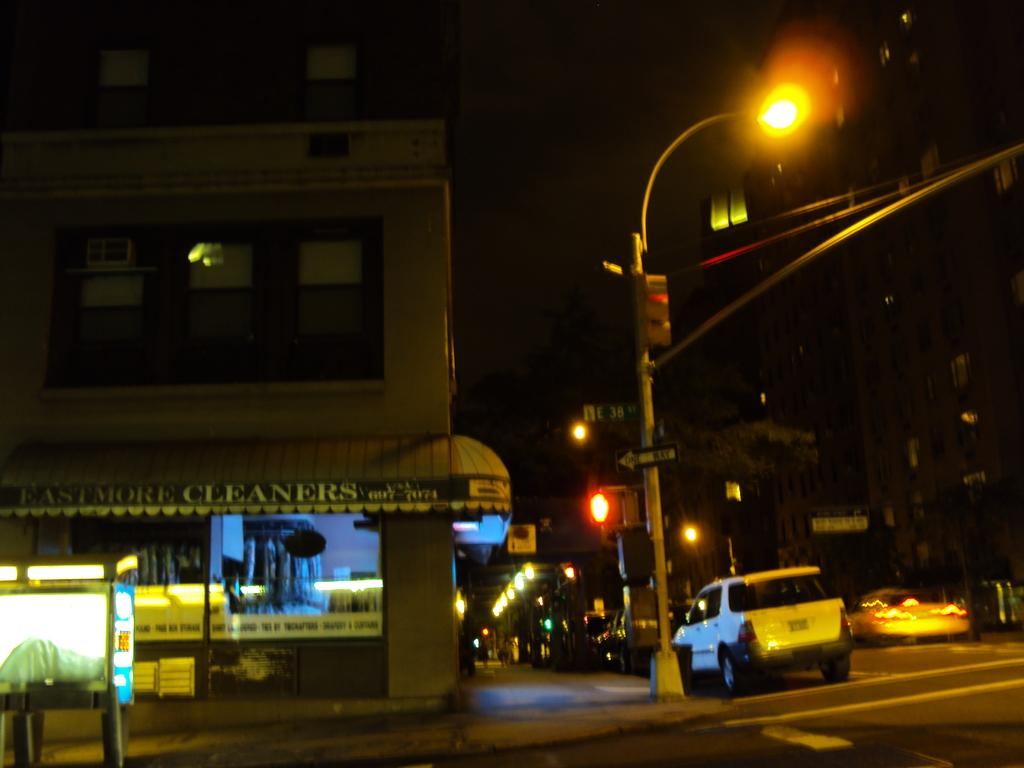<image>
Write a terse but informative summary of the picture. A dark intersection at night with a shop on the corner called Eastmore Cleaners. 